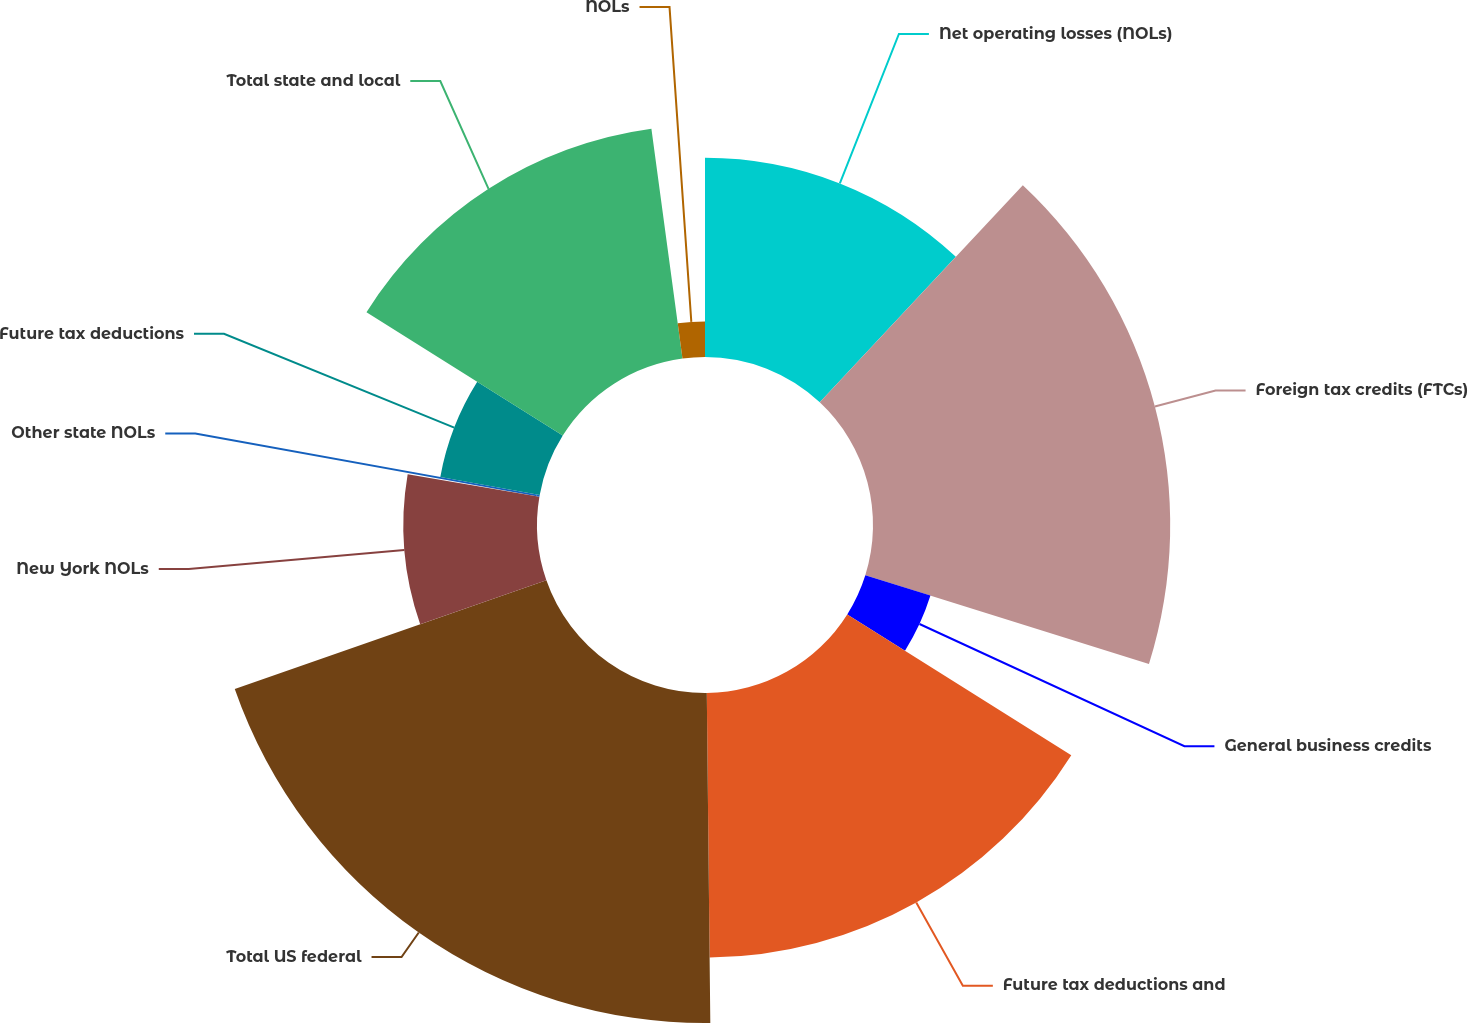Convert chart to OTSL. <chart><loc_0><loc_0><loc_500><loc_500><pie_chart><fcel>Net operating losses (NOLs)<fcel>Foreign tax credits (FTCs)<fcel>General business credits<fcel>Future tax deductions and<fcel>Total US federal<fcel>New York NOLs<fcel>Other state NOLs<fcel>Future tax deductions<fcel>Total state and local<fcel>NOLs<nl><fcel>11.97%<fcel>17.86%<fcel>4.1%<fcel>15.9%<fcel>19.83%<fcel>8.03%<fcel>0.17%<fcel>6.07%<fcel>13.93%<fcel>2.14%<nl></chart> 